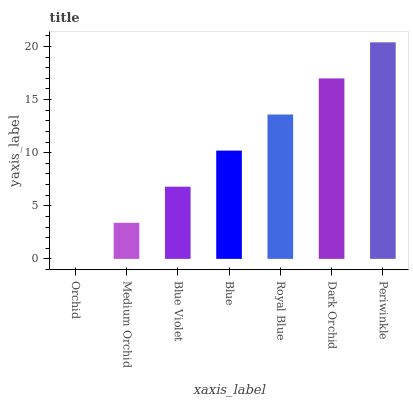Is Orchid the minimum?
Answer yes or no. Yes. Is Periwinkle the maximum?
Answer yes or no. Yes. Is Medium Orchid the minimum?
Answer yes or no. No. Is Medium Orchid the maximum?
Answer yes or no. No. Is Medium Orchid greater than Orchid?
Answer yes or no. Yes. Is Orchid less than Medium Orchid?
Answer yes or no. Yes. Is Orchid greater than Medium Orchid?
Answer yes or no. No. Is Medium Orchid less than Orchid?
Answer yes or no. No. Is Blue the high median?
Answer yes or no. Yes. Is Blue the low median?
Answer yes or no. Yes. Is Periwinkle the high median?
Answer yes or no. No. Is Orchid the low median?
Answer yes or no. No. 